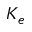Convert formula to latex. <formula><loc_0><loc_0><loc_500><loc_500>K _ { e }</formula> 